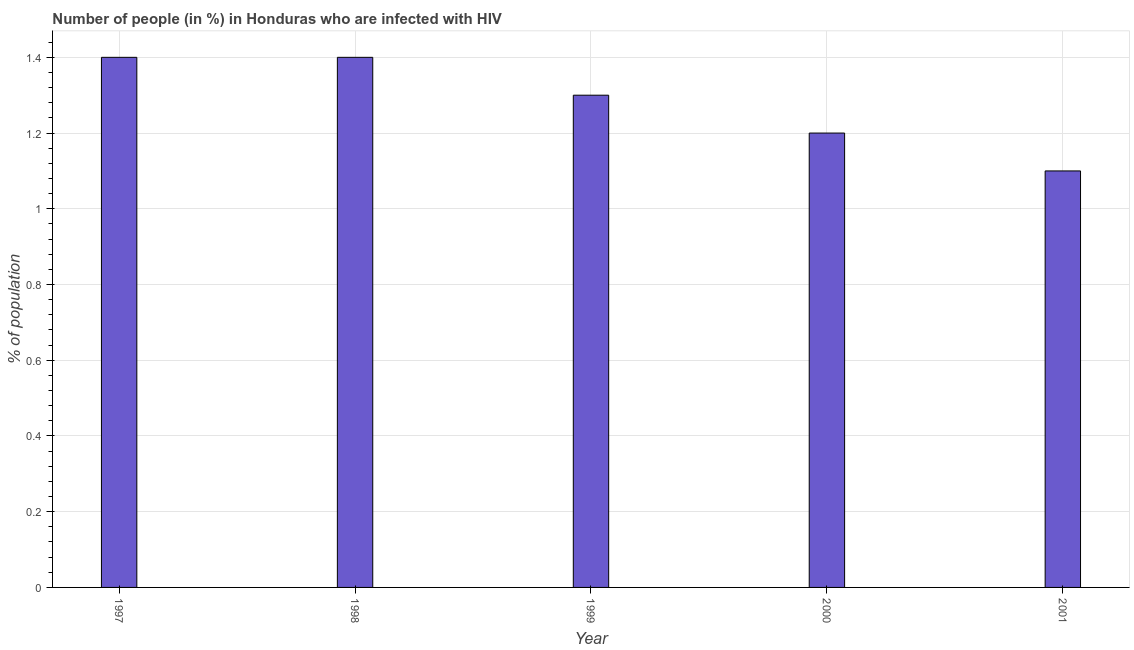Does the graph contain any zero values?
Your response must be concise. No. Does the graph contain grids?
Provide a succinct answer. Yes. What is the title of the graph?
Your answer should be very brief. Number of people (in %) in Honduras who are infected with HIV. What is the label or title of the Y-axis?
Ensure brevity in your answer.  % of population. Across all years, what is the minimum number of people infected with hiv?
Keep it short and to the point. 1.1. What is the difference between the number of people infected with hiv in 1999 and 2000?
Give a very brief answer. 0.1. What is the average number of people infected with hiv per year?
Your answer should be very brief. 1.28. What is the median number of people infected with hiv?
Keep it short and to the point. 1.3. In how many years, is the number of people infected with hiv greater than 1.04 %?
Make the answer very short. 5. What is the ratio of the number of people infected with hiv in 1999 to that in 2001?
Make the answer very short. 1.18. Is the sum of the number of people infected with hiv in 1997 and 2001 greater than the maximum number of people infected with hiv across all years?
Your response must be concise. Yes. Are all the bars in the graph horizontal?
Ensure brevity in your answer.  No. What is the % of population of 1998?
Offer a terse response. 1.4. What is the % of population in 2000?
Offer a terse response. 1.2. What is the % of population in 2001?
Keep it short and to the point. 1.1. What is the difference between the % of population in 1997 and 1999?
Provide a succinct answer. 0.1. What is the difference between the % of population in 1997 and 2000?
Keep it short and to the point. 0.2. What is the difference between the % of population in 1998 and 2000?
Offer a very short reply. 0.2. What is the difference between the % of population in 1999 and 2000?
Your response must be concise. 0.1. What is the difference between the % of population in 2000 and 2001?
Provide a succinct answer. 0.1. What is the ratio of the % of population in 1997 to that in 1999?
Your answer should be compact. 1.08. What is the ratio of the % of population in 1997 to that in 2000?
Keep it short and to the point. 1.17. What is the ratio of the % of population in 1997 to that in 2001?
Keep it short and to the point. 1.27. What is the ratio of the % of population in 1998 to that in 1999?
Offer a very short reply. 1.08. What is the ratio of the % of population in 1998 to that in 2000?
Your answer should be very brief. 1.17. What is the ratio of the % of population in 1998 to that in 2001?
Keep it short and to the point. 1.27. What is the ratio of the % of population in 1999 to that in 2000?
Ensure brevity in your answer.  1.08. What is the ratio of the % of population in 1999 to that in 2001?
Keep it short and to the point. 1.18. What is the ratio of the % of population in 2000 to that in 2001?
Provide a succinct answer. 1.09. 